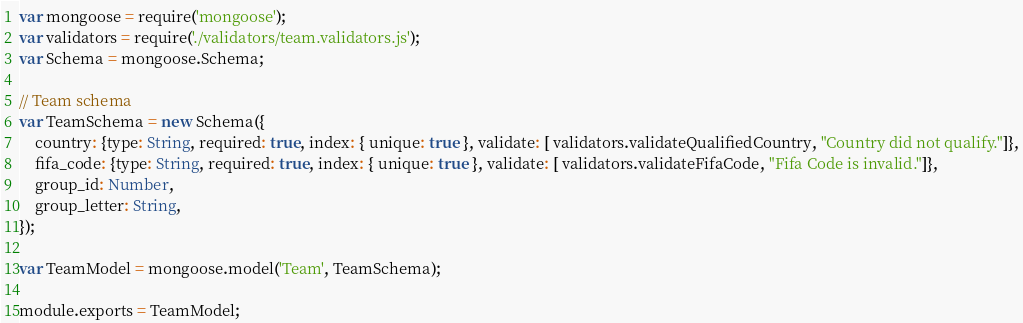<code> <loc_0><loc_0><loc_500><loc_500><_JavaScript_>var mongoose = require('mongoose');
var validators = require('./validators/team.validators.js');
var Schema = mongoose.Schema;

// Team schema
var TeamSchema = new Schema({
    country: {type: String, required: true, index: { unique: true }, validate: [ validators.validateQualifiedCountry, "Country did not qualify."]},
    fifa_code: {type: String, required: true, index: { unique: true }, validate: [ validators.validateFifaCode, "Fifa Code is invalid."]},
    group_id: Number,
    group_letter: String,
});

var TeamModel = mongoose.model('Team', TeamSchema);

module.exports = TeamModel;
</code> 